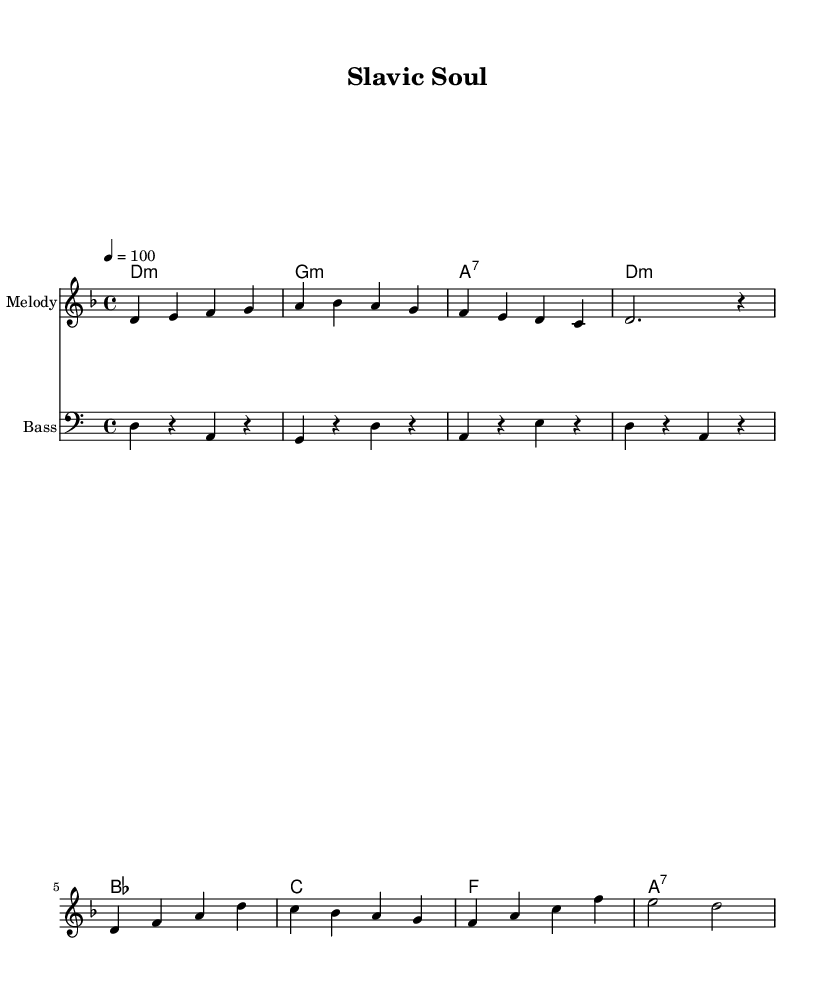What is the key signature of this music? The key signature is D minor, which is indicated by one flat (B flat).
Answer: D minor What is the time signature of this piece? The time signature is 4/4, which means there are four beats in each measure.
Answer: 4/4 What is the tempo of the piece? The tempo is marked as quarter note equal to 100 beats per minute, which indicates a moderately fast speed.
Answer: 100 How many measures are in the melody? By counting the groups of four beats in the melody section, there are a total of 8 measures.
Answer: 8 What is the harmony structure at the beginning? The harmony begins with a D minor chord, followed by G minor, A7, and returns to D minor in the first four measures.
Answer: D minor What type of musical elements are combined in this piece? The piece combines traditional Balkan folk elements with modern hip-hop rhythm and structure, reflecting a fusion style.
Answer: Fusion What is the role of the bass in this score? The bass provides a foundational rhythm that supports the harmony by outlining the root notes of the chords and contributing to the overall groove.
Answer: Foundation 